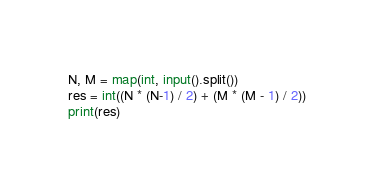<code> <loc_0><loc_0><loc_500><loc_500><_Python_>N, M = map(int, input().split())
res = int((N * (N-1) / 2) + (M * (M - 1) / 2))
print(res)
</code> 